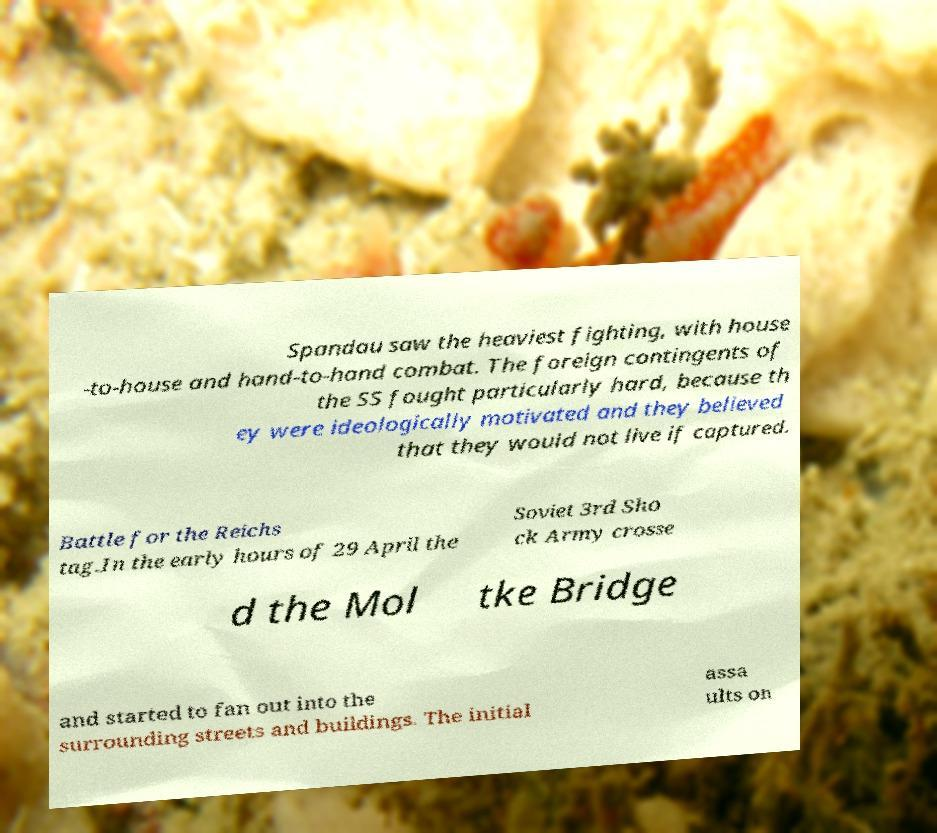Can you read and provide the text displayed in the image?This photo seems to have some interesting text. Can you extract and type it out for me? Spandau saw the heaviest fighting, with house -to-house and hand-to-hand combat. The foreign contingents of the SS fought particularly hard, because th ey were ideologically motivated and they believed that they would not live if captured. Battle for the Reichs tag.In the early hours of 29 April the Soviet 3rd Sho ck Army crosse d the Mol tke Bridge and started to fan out into the surrounding streets and buildings. The initial assa ults on 